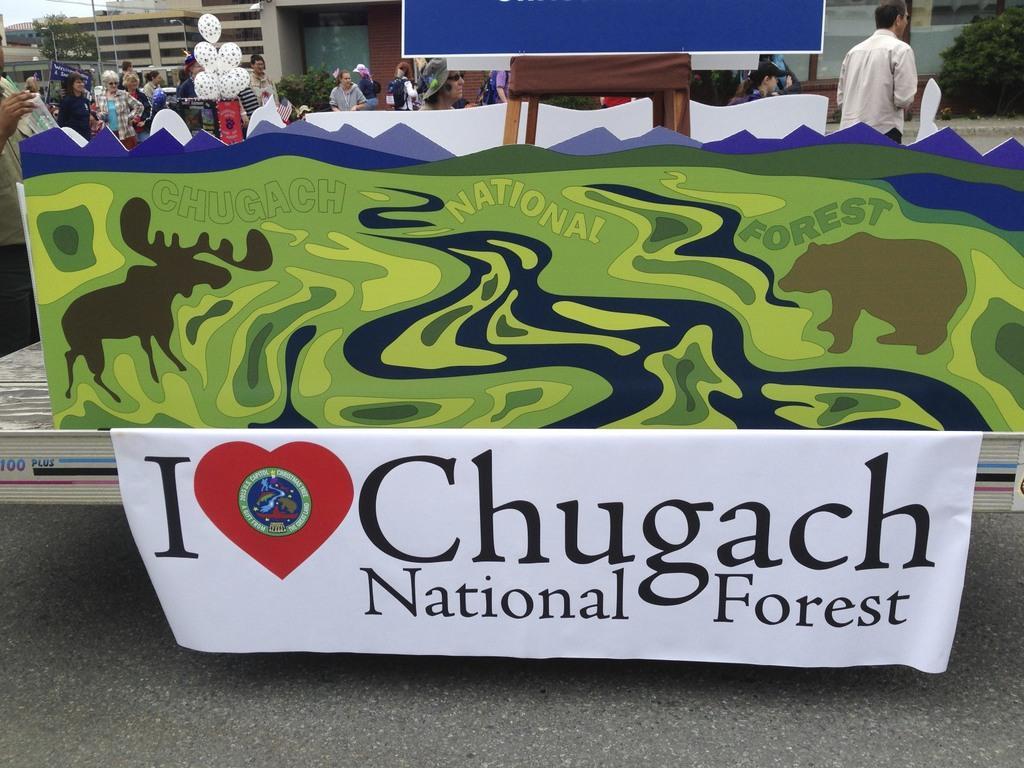How would you summarize this image in a sentence or two? In this image at the bottom we can see a banner attached at the edge to the stage and we can see road. There are pictures on the boards and a person are on the stage. In the background there are few persons, poles, buildings, trees, banners, balloons, plants and sky. 